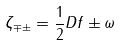<formula> <loc_0><loc_0><loc_500><loc_500>\zeta _ { \mp \pm } = { \frac { 1 } { 2 } } D f \pm \omega</formula> 